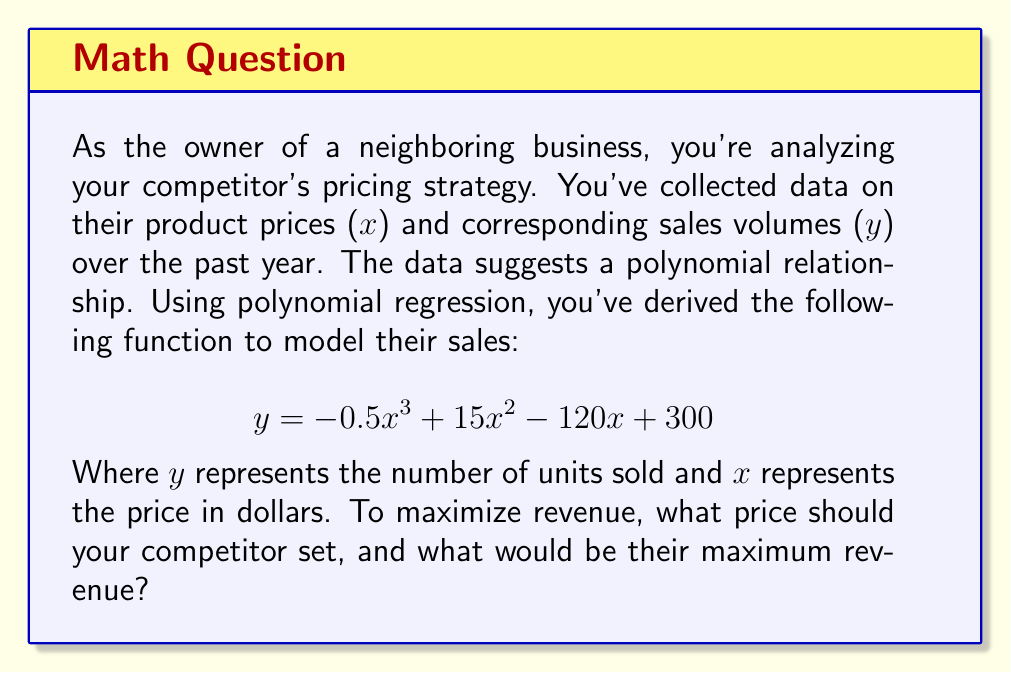Show me your answer to this math problem. To solve this problem, we need to follow these steps:

1) Revenue is calculated by multiplying price by quantity sold. So, the revenue function $R(x)$ is:

   $$R(x) = x \cdot y = x(-0.5x^3 + 15x^2 - 120x + 300)$$

2) Expand this equation:

   $$R(x) = -0.5x^4 + 15x^3 - 120x^2 + 300x$$

3) To find the maximum revenue, we need to find where the derivative of $R(x)$ equals zero:

   $$R'(x) = -2x^3 + 45x^2 - 240x + 300$$

4) Set $R'(x) = 0$ and solve:

   $$-2x^3 + 45x^2 - 240x + 300 = 0$$

   This is a cubic equation. We can solve it using the cubic formula or a graphing calculator. The solutions are approximately:

   $x \approx 2.37, 10.63, 22.50$

5) The second derivative test or checking values on either side of these points reveals that the maximum occurs at $x \approx 10.63$.

6) Round to two decimal places: The optimal price is $10.63.

7) To find the maximum revenue, plug this value back into the original revenue function:

   $$R(10.63) = 10.63(-0.5(10.63)^3 + 15(10.63)^2 - 120(10.63) + 300)$$

8) Calculate this value: $R(10.63) \approx 1060.75$

Therefore, the maximum revenue is approximately $1060.75.
Answer: The optimal price is $10.63, and the maximum revenue is $1060.75. 